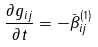<formula> <loc_0><loc_0><loc_500><loc_500>\frac { \partial g _ { i j } } { \partial t } = - { \bar { \beta } } ^ { ( 1 ) } _ { i j }</formula> 